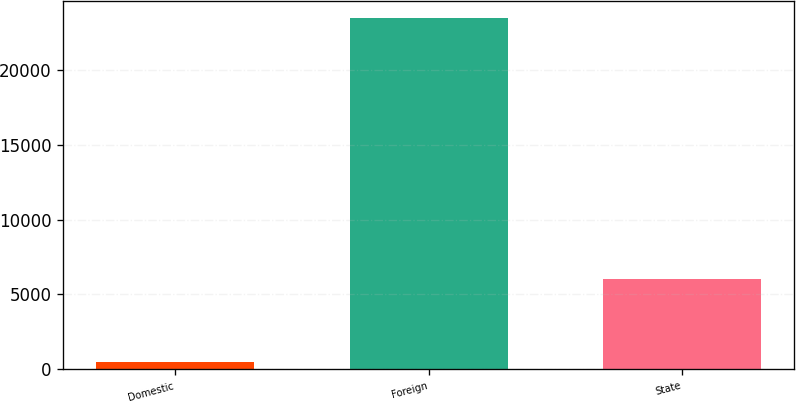Convert chart. <chart><loc_0><loc_0><loc_500><loc_500><bar_chart><fcel>Domestic<fcel>Foreign<fcel>State<nl><fcel>452<fcel>23471<fcel>6007<nl></chart> 